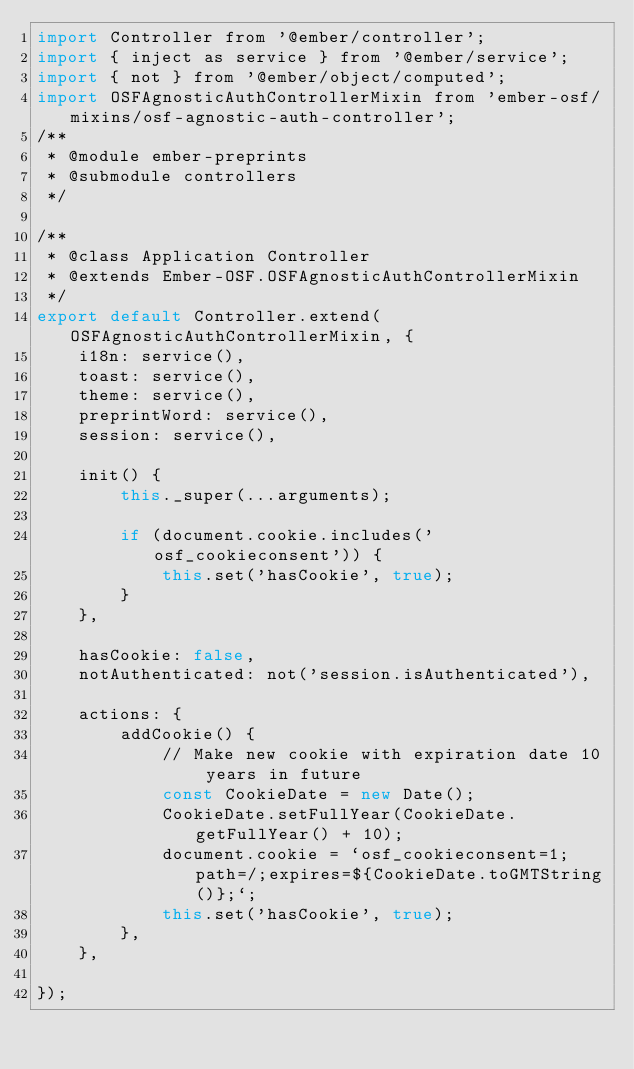<code> <loc_0><loc_0><loc_500><loc_500><_JavaScript_>import Controller from '@ember/controller';
import { inject as service } from '@ember/service';
import { not } from '@ember/object/computed';
import OSFAgnosticAuthControllerMixin from 'ember-osf/mixins/osf-agnostic-auth-controller';
/**
 * @module ember-preprints
 * @submodule controllers
 */

/**
 * @class Application Controller
 * @extends Ember-OSF.OSFAgnosticAuthControllerMixin
 */
export default Controller.extend(OSFAgnosticAuthControllerMixin, {
    i18n: service(),
    toast: service(),
    theme: service(),
    preprintWord: service(),
    session: service(),

    init() {
        this._super(...arguments);

        if (document.cookie.includes('osf_cookieconsent')) {
            this.set('hasCookie', true);
        }
    },

    hasCookie: false,
    notAuthenticated: not('session.isAuthenticated'),

    actions: {
        addCookie() {
            // Make new cookie with expiration date 10 years in future
            const CookieDate = new Date();
            CookieDate.setFullYear(CookieDate.getFullYear() + 10);
            document.cookie = `osf_cookieconsent=1;path=/;expires=${CookieDate.toGMTString()};`;
            this.set('hasCookie', true);
        },
    },

});
</code> 